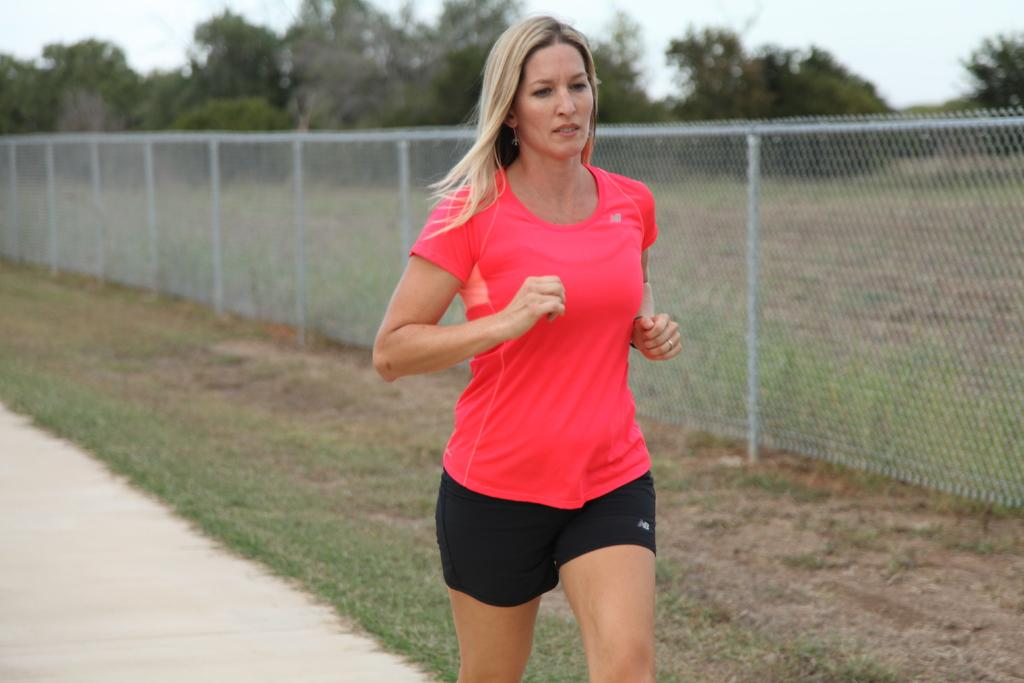What is the lady in the image doing? The lady is jogging in the image. What can be seen in the background of the image? There is a fence and trees in the background of the image. What is visible in the sky in the image? The sky is visible in the image. What type of terrain is at the bottom of the image? There is grass at the bottom of the image. What type of corn is being taught to the lady in the image? There is no corn or teaching depicted in the image; it features a lady jogging. What sound does the bell make in the image? There is no bell present in the image. 